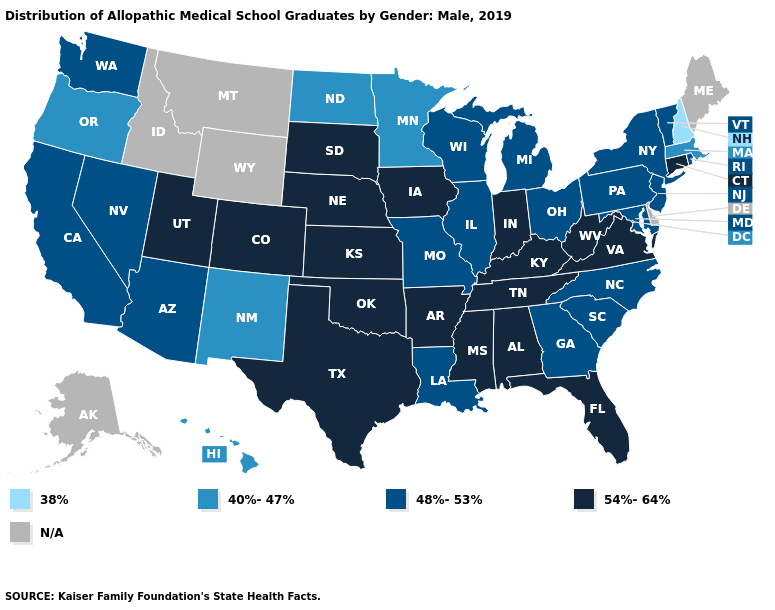What is the highest value in states that border West Virginia?
Write a very short answer. 54%-64%. What is the lowest value in states that border Kansas?
Be succinct. 48%-53%. Is the legend a continuous bar?
Answer briefly. No. Name the states that have a value in the range 48%-53%?
Be succinct. Arizona, California, Georgia, Illinois, Louisiana, Maryland, Michigan, Missouri, Nevada, New Jersey, New York, North Carolina, Ohio, Pennsylvania, Rhode Island, South Carolina, Vermont, Washington, Wisconsin. What is the highest value in states that border Pennsylvania?
Be succinct. 54%-64%. Does the map have missing data?
Quick response, please. Yes. What is the value of Rhode Island?
Concise answer only. 48%-53%. Among the states that border Maine , which have the lowest value?
Concise answer only. New Hampshire. What is the value of Maine?
Keep it brief. N/A. What is the highest value in states that border Kansas?
Quick response, please. 54%-64%. Does Oregon have the lowest value in the West?
Write a very short answer. Yes. Among the states that border Utah , which have the lowest value?
Quick response, please. New Mexico. 